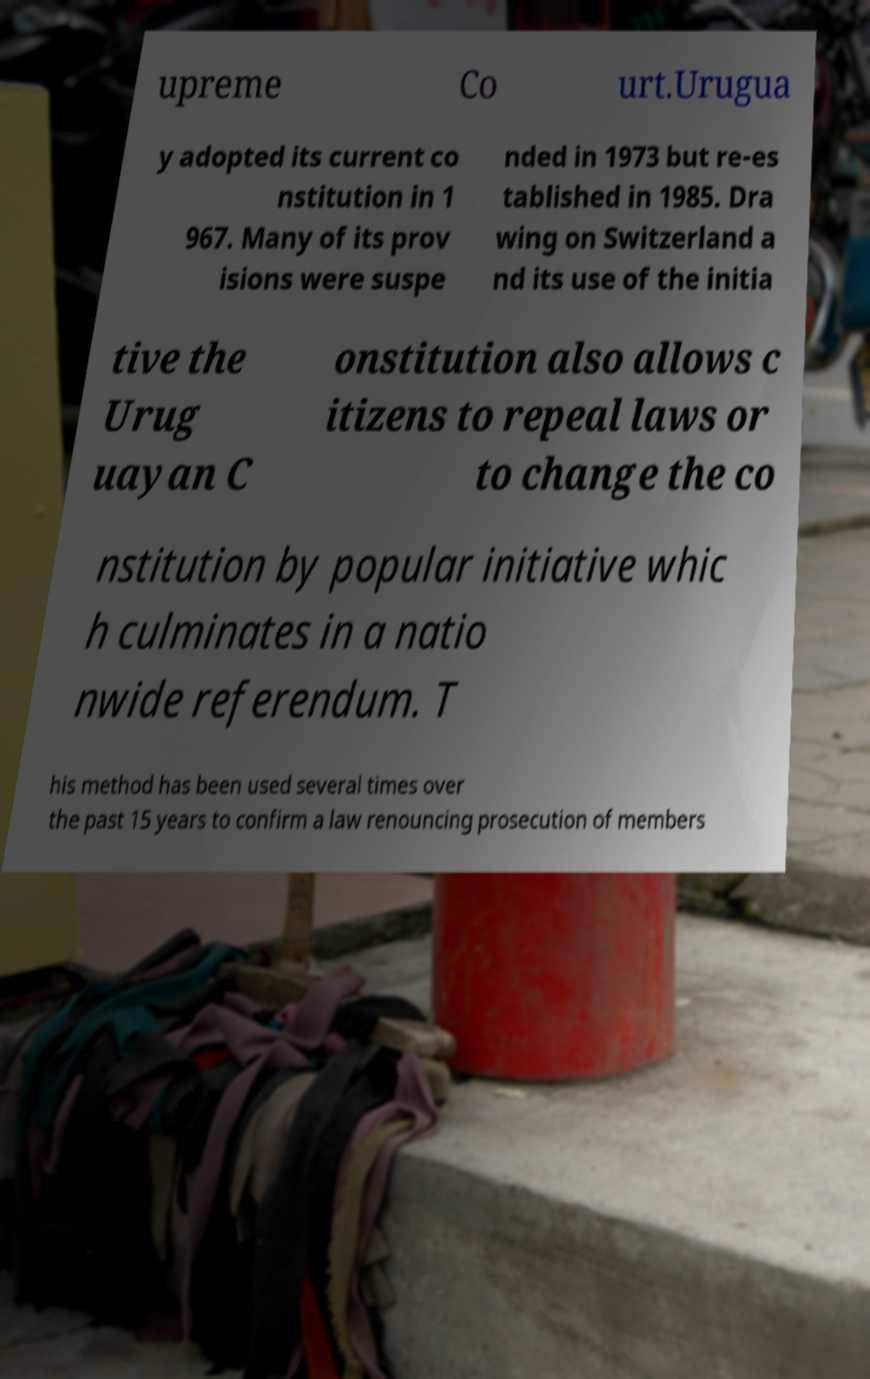Can you accurately transcribe the text from the provided image for me? upreme Co urt.Urugua y adopted its current co nstitution in 1 967. Many of its prov isions were suspe nded in 1973 but re-es tablished in 1985. Dra wing on Switzerland a nd its use of the initia tive the Urug uayan C onstitution also allows c itizens to repeal laws or to change the co nstitution by popular initiative whic h culminates in a natio nwide referendum. T his method has been used several times over the past 15 years to confirm a law renouncing prosecution of members 